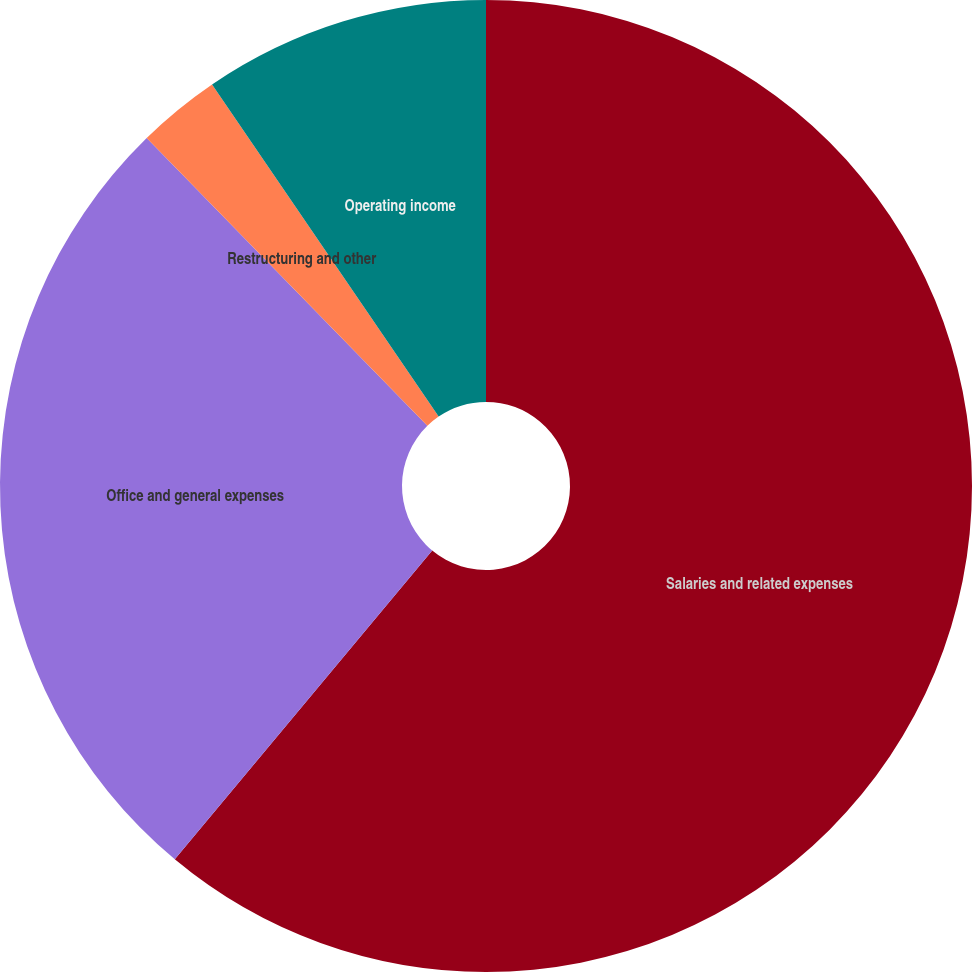<chart> <loc_0><loc_0><loc_500><loc_500><pie_chart><fcel>Salaries and related expenses<fcel>Office and general expenses<fcel>Restructuring and other<fcel>Operating income<nl><fcel>61.06%<fcel>26.64%<fcel>2.77%<fcel>9.53%<nl></chart> 